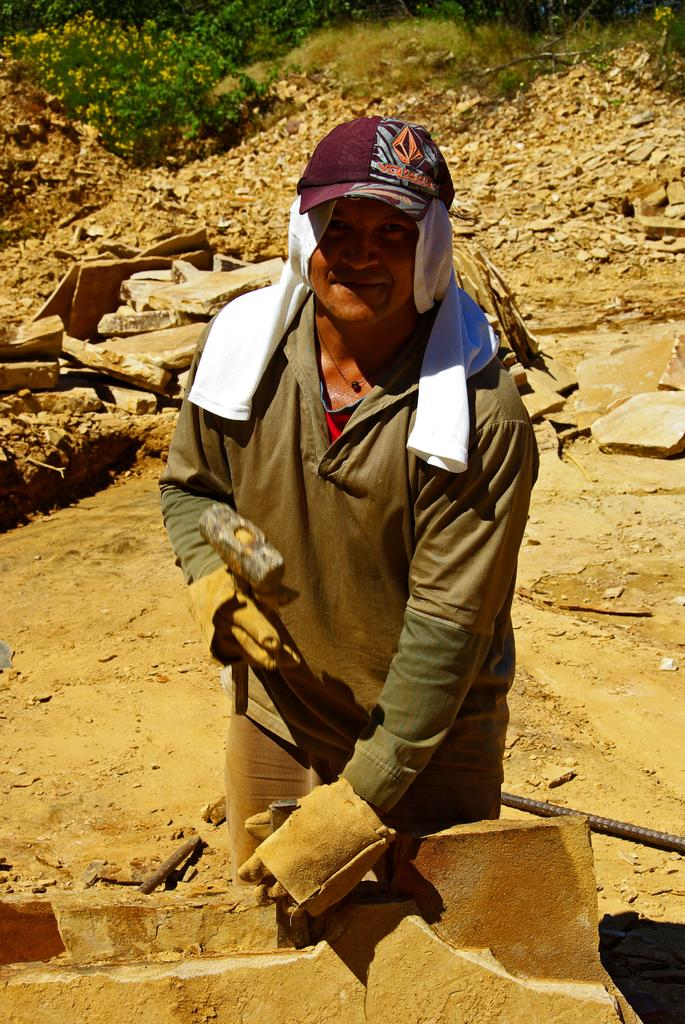What is the main subject in the image? There is a person standing in the image. What type of terrain is visible in the image? Soil, rocks, and plants are visible in the image. Can you describe the plants in the image? There are plants in the image, but their specific type is not mentioned. What type of agreement is being signed by the person in the image? There is no indication of a signing or agreement in the image; it only shows a person standing amidst soil, rocks, and plants. Can you see a hammer in the image? There is no hammer present in the image. 